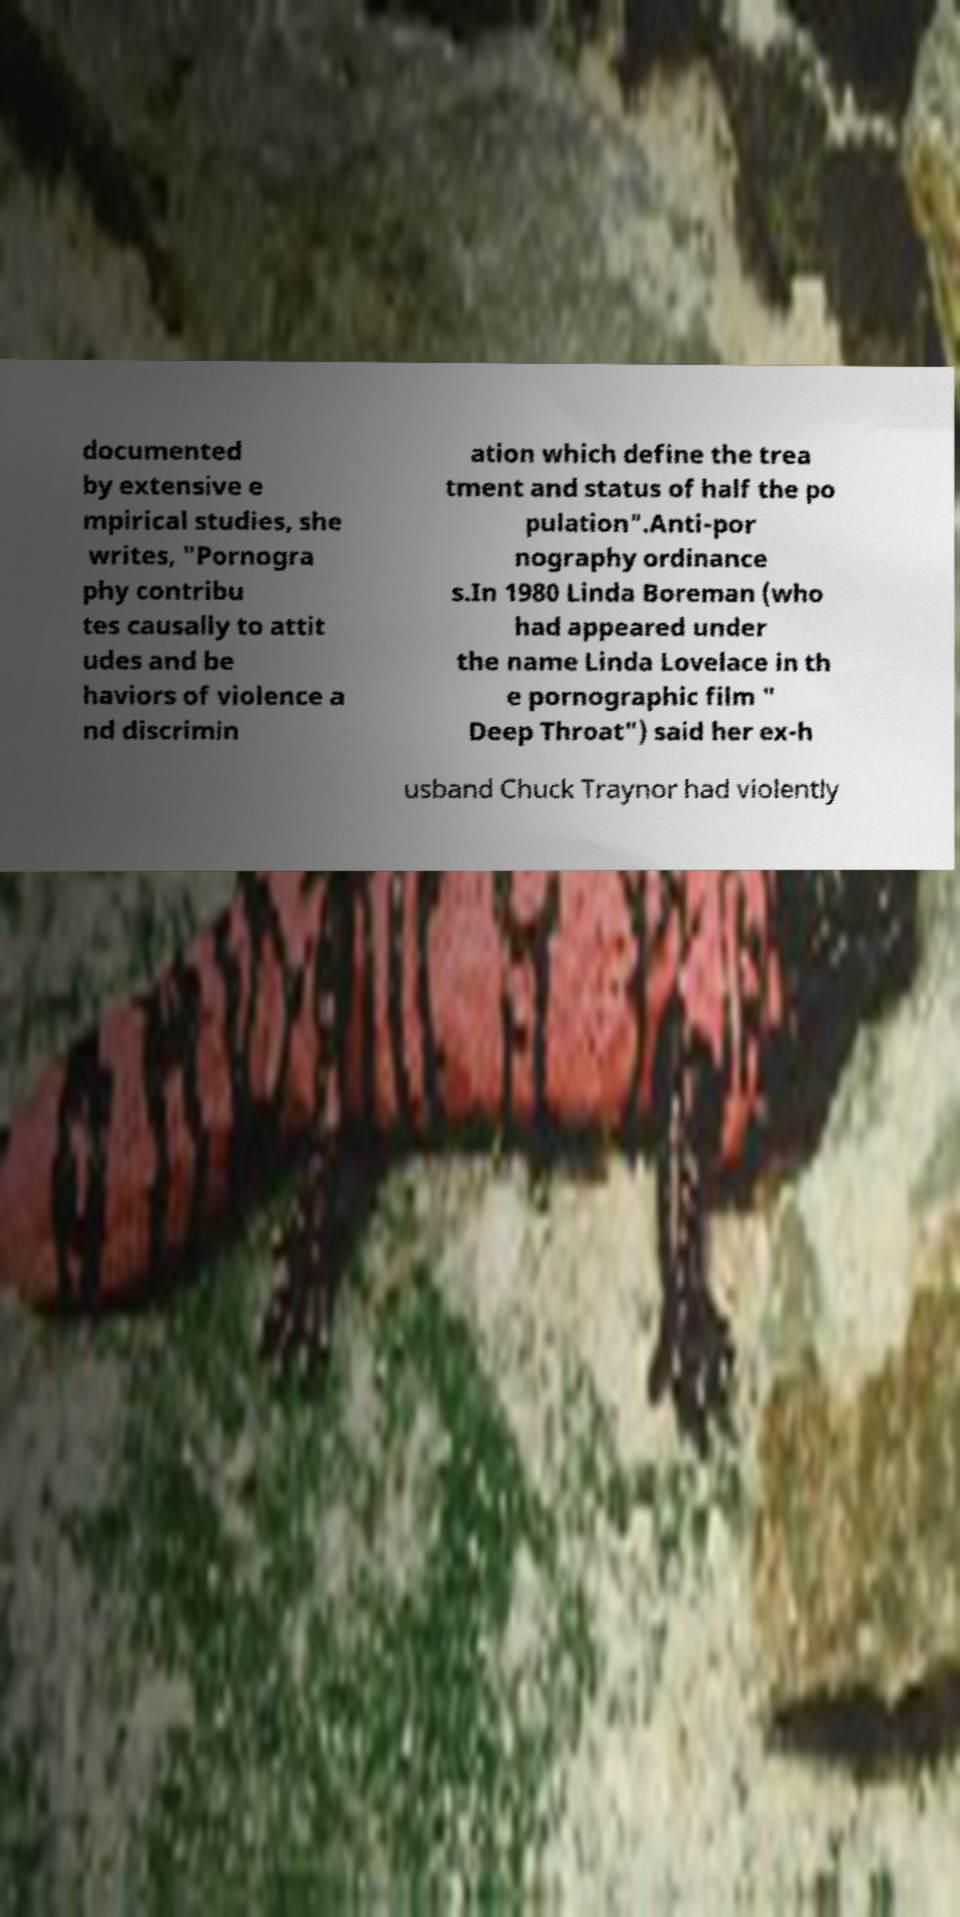Could you assist in decoding the text presented in this image and type it out clearly? documented by extensive e mpirical studies, she writes, "Pornogra phy contribu tes causally to attit udes and be haviors of violence a nd discrimin ation which define the trea tment and status of half the po pulation".Anti-por nography ordinance s.In 1980 Linda Boreman (who had appeared under the name Linda Lovelace in th e pornographic film " Deep Throat") said her ex-h usband Chuck Traynor had violently 